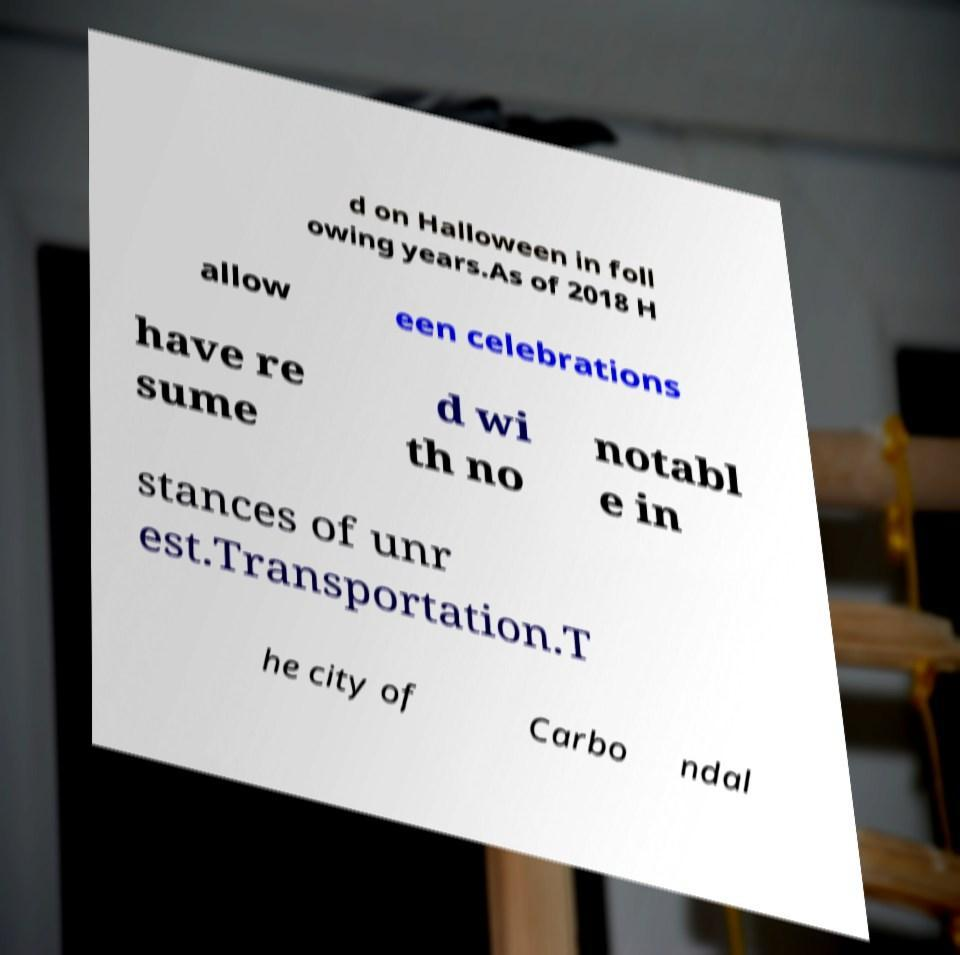Could you extract and type out the text from this image? d on Halloween in foll owing years.As of 2018 H allow een celebrations have re sume d wi th no notabl e in stances of unr est.Transportation.T he city of Carbo ndal 